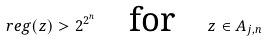<formula> <loc_0><loc_0><loc_500><loc_500>\ r e g ( z ) > 2 ^ { 2 ^ { n } } \quad \text {for} \quad z \in A _ { j , n }</formula> 